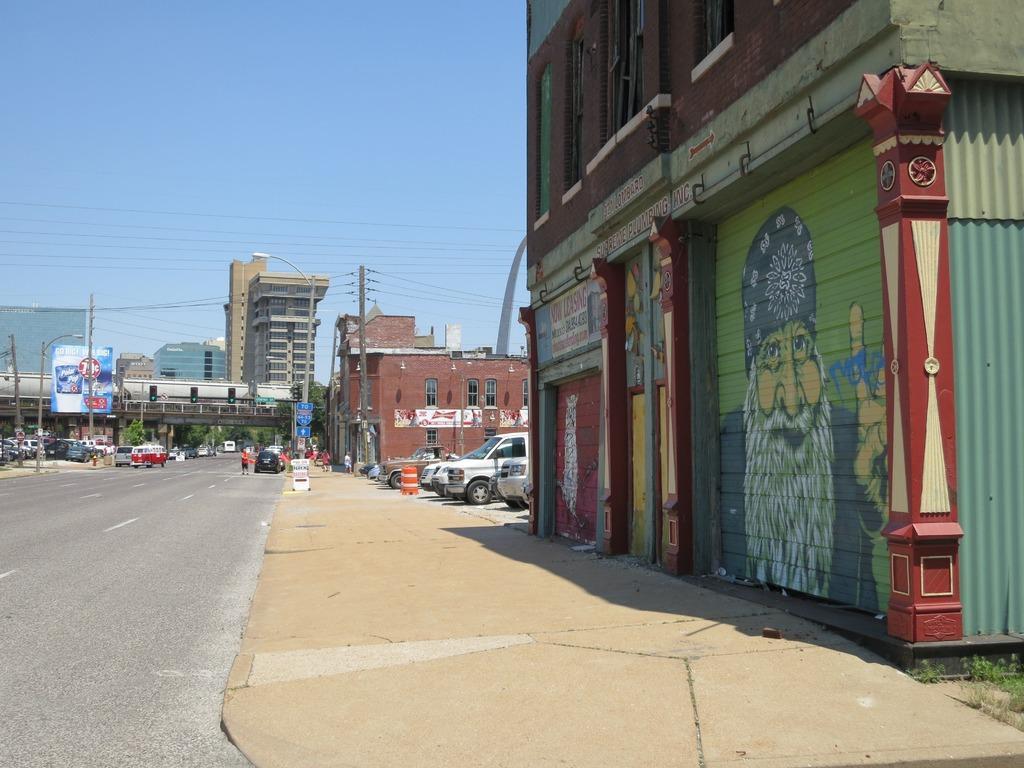Could you give a brief overview of what you see in this image? In the center of the image we can see buildings, bridge, traffic lights, electric light pole, boards, vehicles, some persons, wires, wall are there. At the top of the image sky is there. At the bottom of the image road is there. 